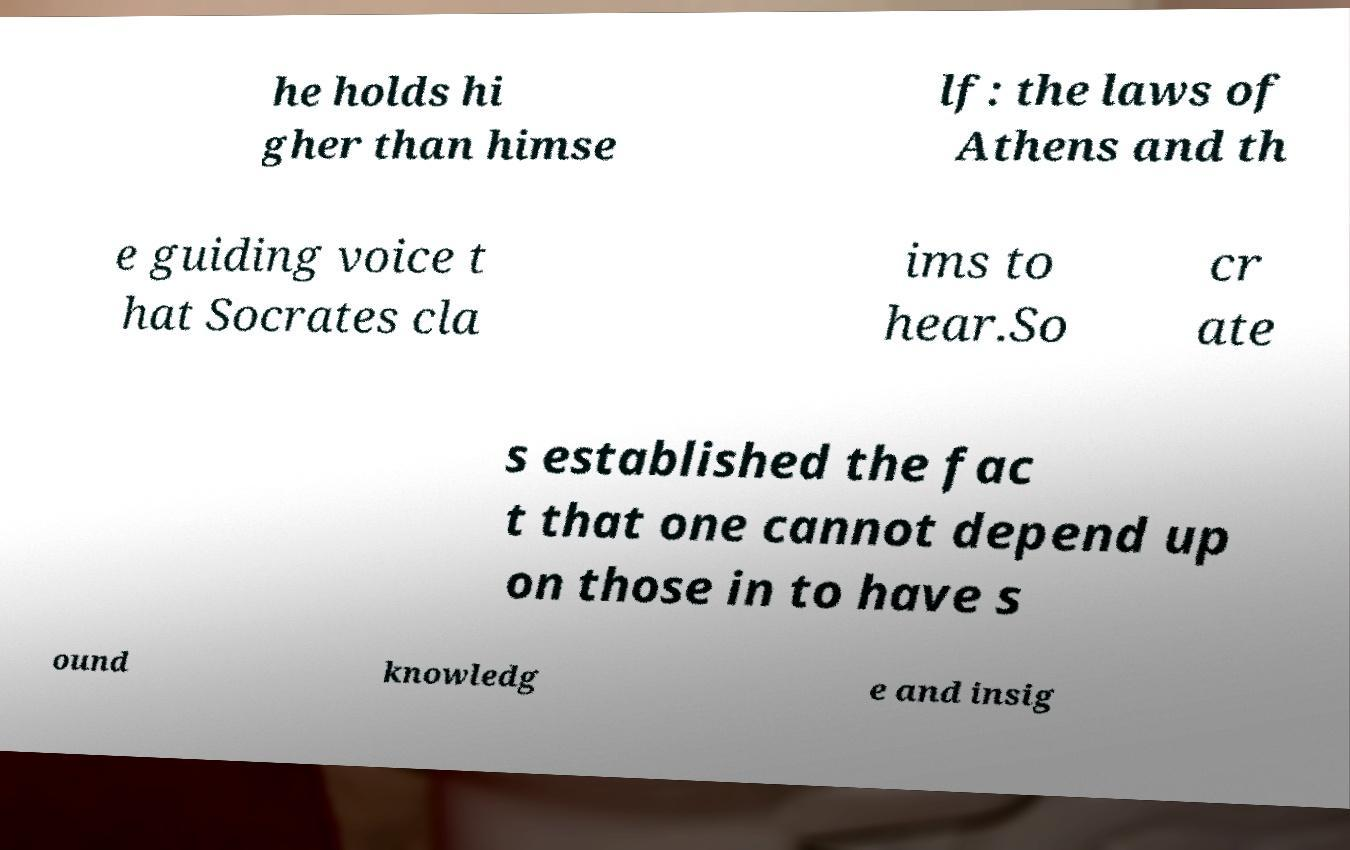There's text embedded in this image that I need extracted. Can you transcribe it verbatim? he holds hi gher than himse lf: the laws of Athens and th e guiding voice t hat Socrates cla ims to hear.So cr ate s established the fac t that one cannot depend up on those in to have s ound knowledg e and insig 